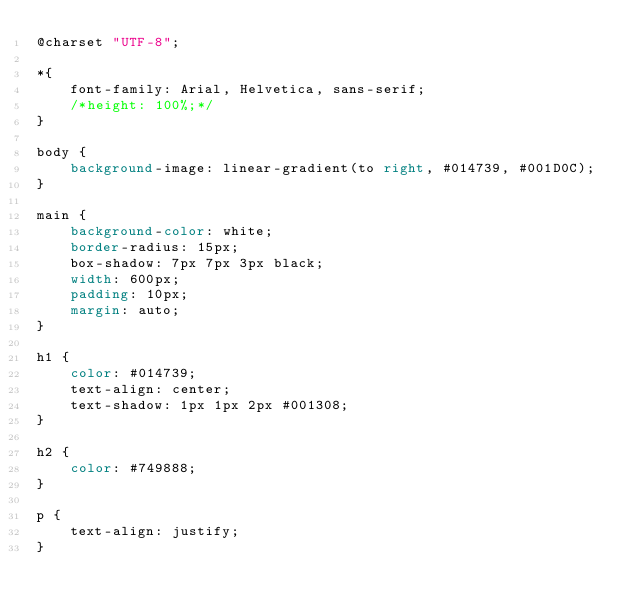Convert code to text. <code><loc_0><loc_0><loc_500><loc_500><_CSS_>@charset "UTF-8";

*{
    font-family: Arial, Helvetica, sans-serif;
    /*height: 100%;*/
}

body {
    background-image: linear-gradient(to right, #014739, #001D0C);
}

main {
    background-color: white;
    border-radius: 15px;
    box-shadow: 7px 7px 3px black;
    width: 600px;
    padding: 10px;
    margin: auto;
}

h1 {
    color: #014739;
    text-align: center;
    text-shadow: 1px 1px 2px #001308;
}

h2 { 
    color: #749888;
}

p {
    text-align: justify;
}</code> 